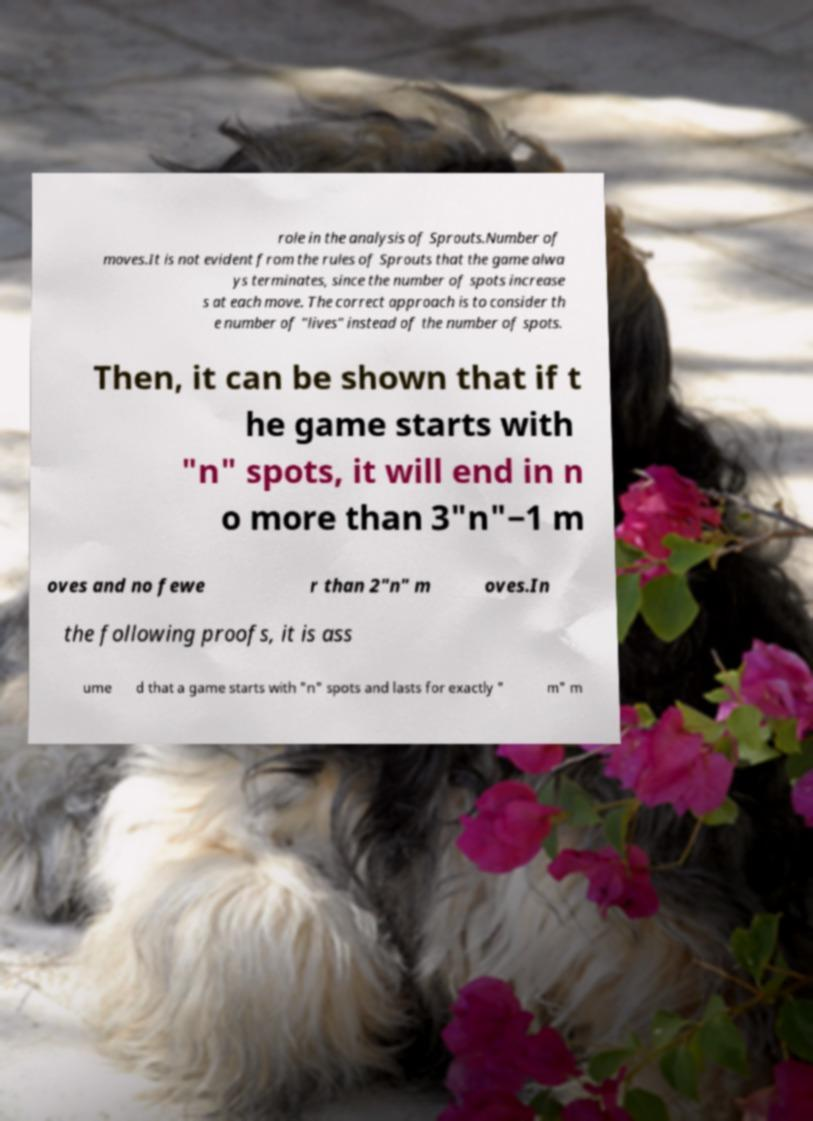Please read and relay the text visible in this image. What does it say? role in the analysis of Sprouts.Number of moves.It is not evident from the rules of Sprouts that the game alwa ys terminates, since the number of spots increase s at each move. The correct approach is to consider th e number of "lives" instead of the number of spots. Then, it can be shown that if t he game starts with "n" spots, it will end in n o more than 3"n"−1 m oves and no fewe r than 2"n" m oves.In the following proofs, it is ass ume d that a game starts with "n" spots and lasts for exactly " m" m 